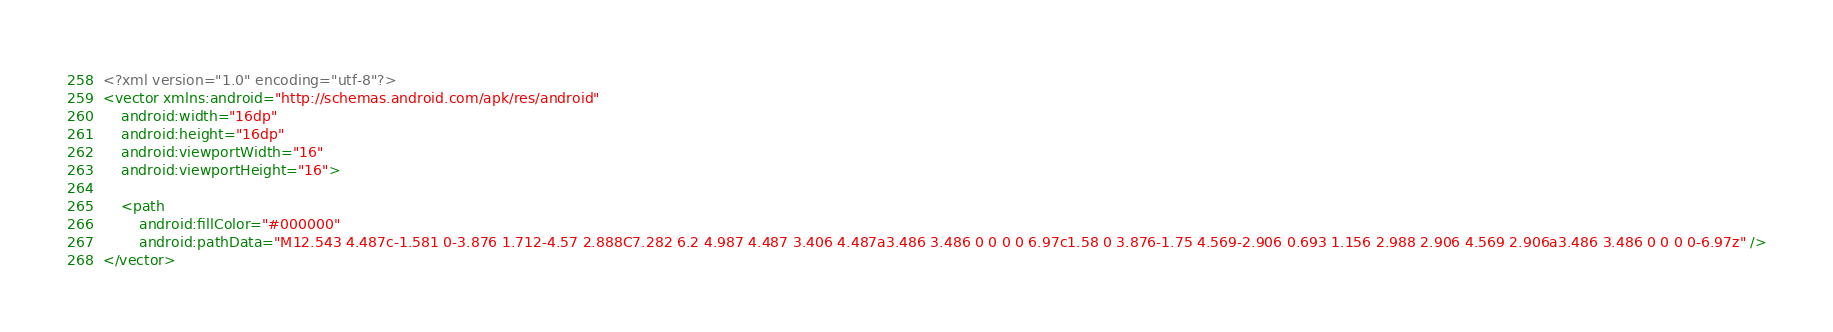<code> <loc_0><loc_0><loc_500><loc_500><_XML_><?xml version="1.0" encoding="utf-8"?>
<vector xmlns:android="http://schemas.android.com/apk/res/android"
    android:width="16dp"
    android:height="16dp"
    android:viewportWidth="16"
    android:viewportHeight="16">

    <path
        android:fillColor="#000000"
        android:pathData="M12.543 4.487c-1.581 0-3.876 1.712-4.57 2.888C7.282 6.2 4.987 4.487 3.406 4.487a3.486 3.486 0 0 0 0 6.97c1.58 0 3.876-1.75 4.569-2.906 0.693 1.156 2.988 2.906 4.569 2.906a3.486 3.486 0 0 0 0-6.97z" />
</vector></code> 